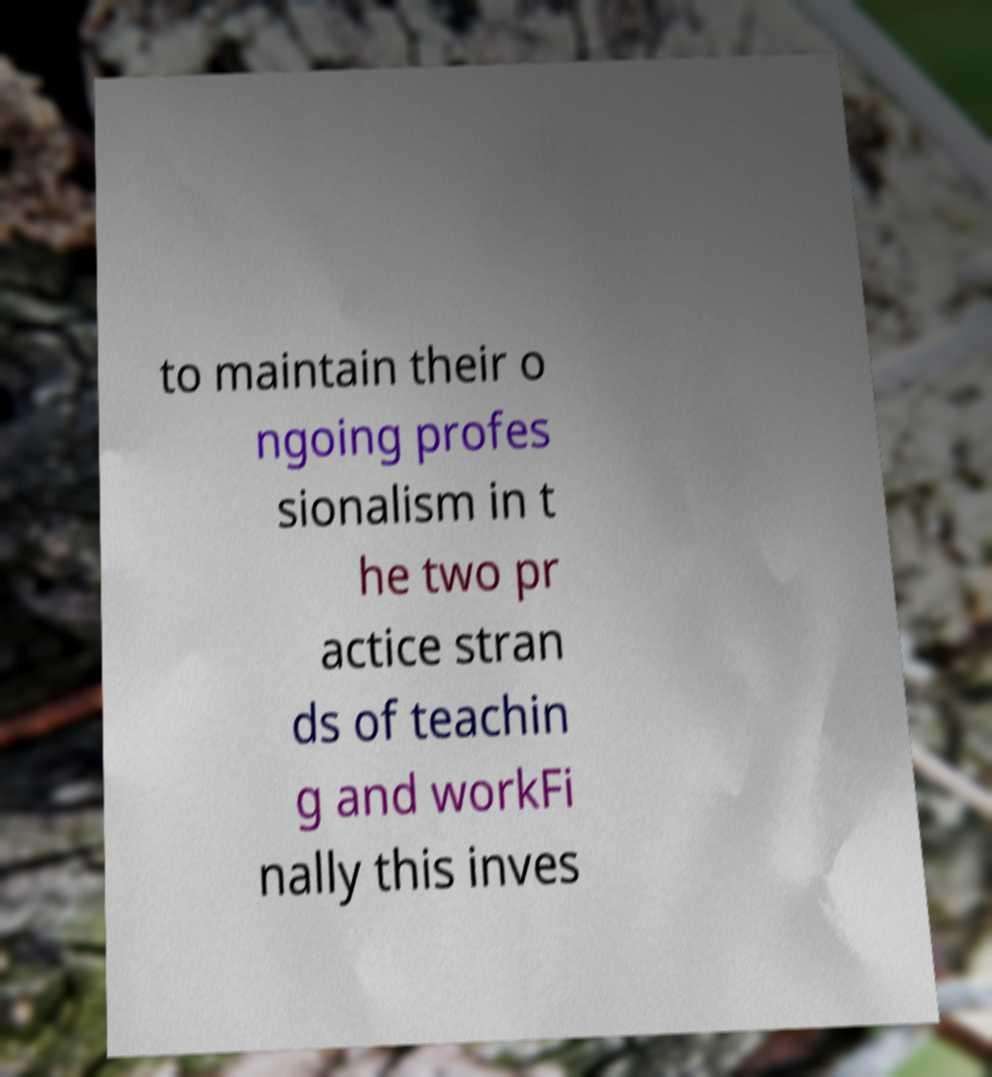Please identify and transcribe the text found in this image. to maintain their o ngoing profes sionalism in t he two pr actice stran ds of teachin g and workFi nally this inves 